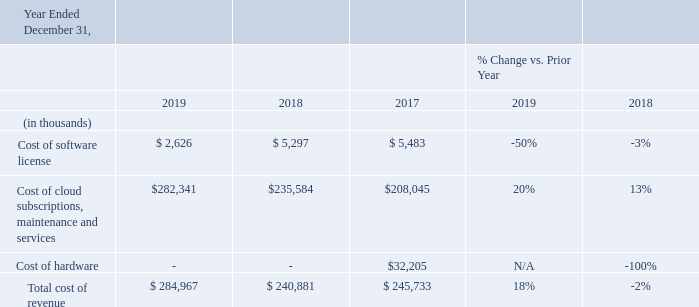Cost of Software License Cost of software license consists of the costs associated with software reproduction; media, packaging and delivery; documentation, and other related costs; and royalties on third-party software sold with or as part of our products. In 2019, cost of license decreased by $2.7 million, compared to 2018 principally due to a $1.7 million decrease in third-party software license fees and a $1.0 million decrease in royalty costs. In 2018, cost of software license decreased $0.2 million compared to 2017 principally due to the decrease in license revenue which resulted in lower royalty costs. Royalty costs decreased $2.1 million and were partially offset by a $1.7 million increase in third-party software license fees.
Cost of Cloud Subscriptions, Maintenance and Services Year 2019 compared with year 2018 Cost of cloud subscriptions, maintenance and services consists primarily of salaries and other personnel-related expenses of employees dedicated to cloud subscriptions; maintenance services; and professional and technical services as well as hosting fees. The $46.8 million increase in 2019 compared to 2018 was principally due to a $25.8 million increase in compensation and other personnelrelated expense resulting from increased headcount in cloud operations and professional services, a $9.4 million increase in performance-based compensation expense, and a $8.5 million increase in computer infrastructure costs related to cloud business transition. Year 2019 compared with year 2018 Cost of cloud subscriptions, maintenance and services consists primarily of salaries and other personnel-related expenses of employees dedicated to cloud subscriptions; maintenance services; and professional and technical services as well as hosting fees. The $46.8 million increase in 2019 compared to 2018 was principally due to a $25.8 million increase in compensation and other personnelrelated expense resulting from increased headcount in cloud operations and professional services, a $9.4 million increase in performance-based compensation expense, and a $8.5 million increase in computer infrastructure costs related to cloud business transition.
Year 2019 compared with year 2018
Cost of cloud subscriptions, maintenance and services consists primarily of salaries and other personnel-related expenses of
employees dedicated to cloud subscriptions; maintenance services; and professional and technical services as well as hosting fees. The
$46.8 million increase in 2019 compared to 2018 was principally due to a $25.8 million increase in compensation and other personnel related
expense resulting from increased headcount in cloud operations and professional services, a $9.4 million increase in
performance-based compensation expense, and a $8.5 million increase in computer infrastructure costs related to cloud business
transition.
Year 2018 compared with year 2017
The $27.5 million increase in 2018 compared to 2017 was principally due to an $11.6 million increase in performance-based
compensation expense, an $8.8 million increase in computer infrastructure cost related to cloud business transition, and a $7.0 million
increase in other compensation and other personnel-related expenses resulting from increased headcount in professional services.
Cost of Hardware
As discussed above, we adopted the new revenue recognition standard as of January 1, 2018. As a result, we now recognize our
hardware revenue net of related costs which reduces both hardware revenue and cost of sales as compared to our accounting prior to
2018. Had we presented the results for 2017 under ASC 606, cost of hardware would have been presented as zero as we would have
recognized our hardware revenue net of related costs. In 2019, cost of hardware decreased $3.5 million compared to 2018 on
decreased hardware sales, while in 2018, cost of hardware increased $3.7 million compared with 2017 on increased hardware sales
What is the total cost of revenue in 2019?
Answer scale should be: thousand. $ 284,967. What caused the cost of software license to go down in 2019? A $1.7 million decrease in third-party software license fees and a $1.0 million decrease in royalty costs. Why did cost of hardware goes to zero in 2019 and 2018?  Adopted the new revenue recognition standard as of january 1, 2018. What is the difference between cost of software license and cost of cloud subscriptions, maintenance and services in 2019?
Answer scale should be: thousand. $282,341-$2,626
Answer: 279715. Which years had the highest total cost of revenue? 284,967> 245,733> 240,881
Answer: 2019. What is the change in the total cost of revenue between 2018 and 2019?
Answer scale should be: thousand. 284,967-240,881
Answer: 44086. 